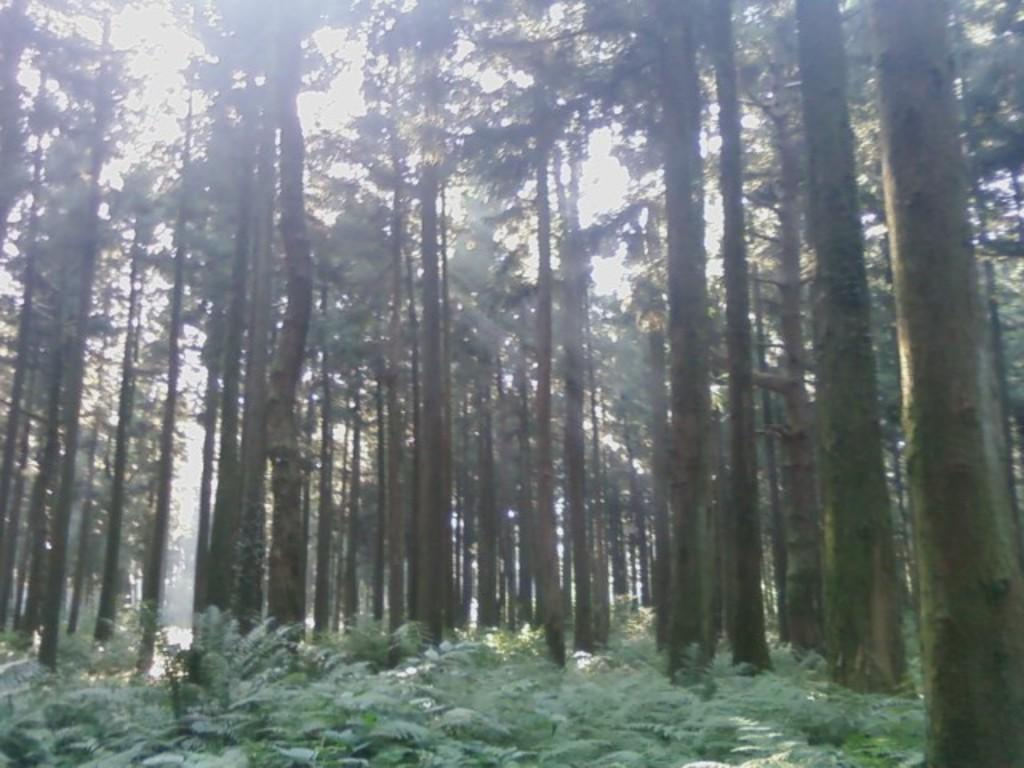What type of vegetation can be seen in the image? There are trees and plants in the image. What part of the natural environment is visible in the image? The sky is visible in the image. How many strings are attached to the chin in the image? There is no chin or string present in the image. 